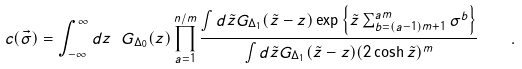Convert formula to latex. <formula><loc_0><loc_0><loc_500><loc_500>c ( \vec { \sigma } ) = \int _ { - \infty } ^ { \infty } d z \ G _ { \Delta _ { 0 } } ( z ) \prod _ { a = 1 } ^ { n / m } \frac { \int d \tilde { z } G _ { \Delta _ { 1 } } ( \tilde { z } - z ) \exp \left \{ \tilde { z } \sum _ { b = ( a - 1 ) m + 1 } ^ { a m } \sigma ^ { b } \right \} } { \int d \tilde { z } G _ { \Delta _ { 1 } } ( \tilde { z } - z ) ( 2 \cosh \tilde { z } ) ^ { m } } \quad .</formula> 